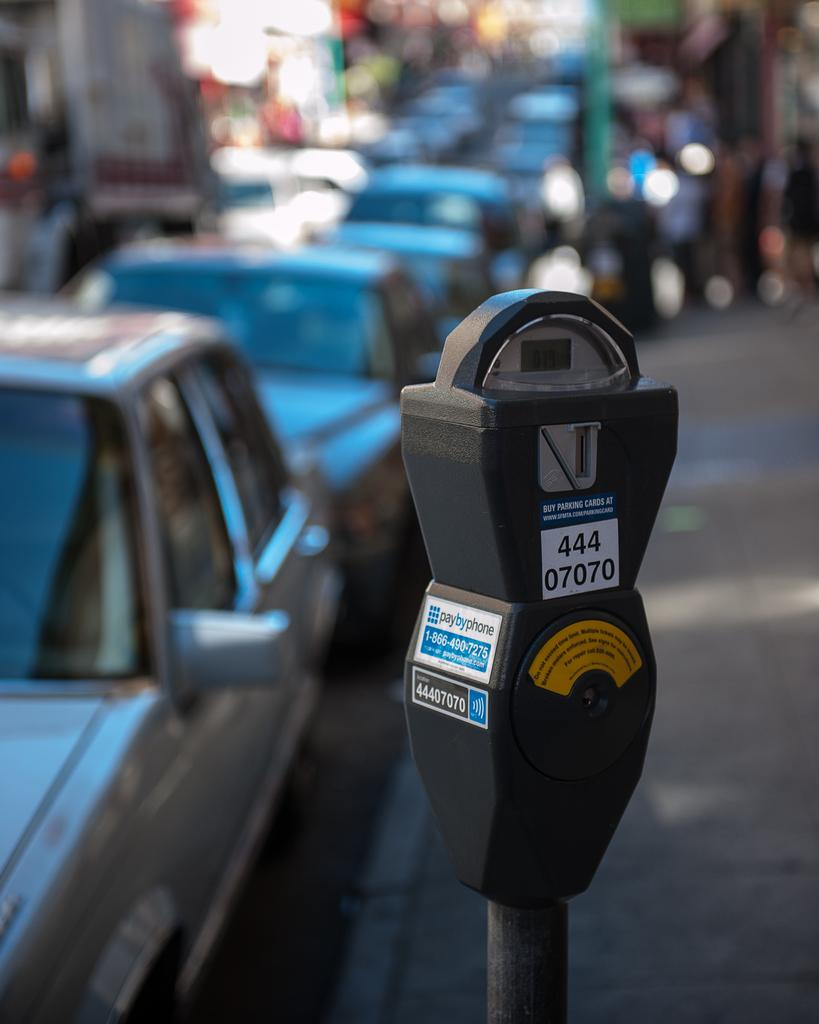<image>
Give a short and clear explanation of the subsequent image. A paybyphone parking meter with cars parked by it. 